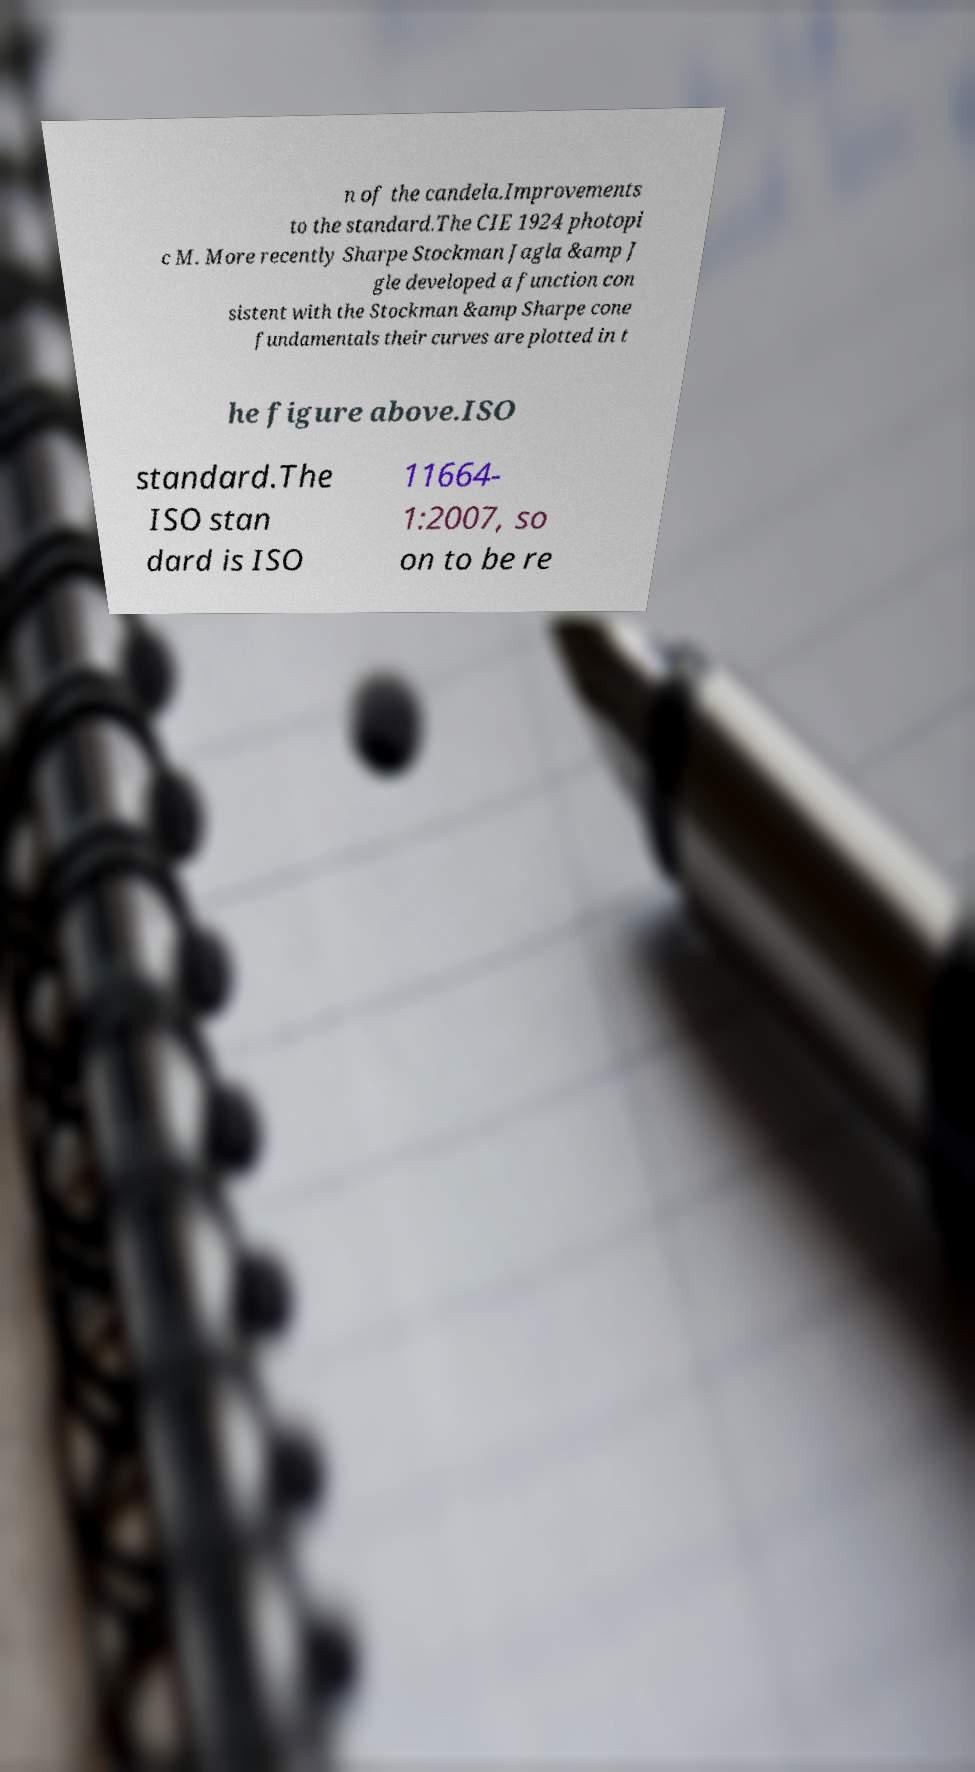For documentation purposes, I need the text within this image transcribed. Could you provide that? n of the candela.Improvements to the standard.The CIE 1924 photopi c M. More recently Sharpe Stockman Jagla &amp J gle developed a function con sistent with the Stockman &amp Sharpe cone fundamentals their curves are plotted in t he figure above.ISO standard.The ISO stan dard is ISO 11664- 1:2007, so on to be re 